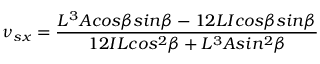<formula> <loc_0><loc_0><loc_500><loc_500>\nu { _ { s x } } = \frac { L ^ { 3 } A \cos \beta \sin \beta - 1 2 L I \cos \beta \sin \beta } { 1 2 I L \cos ^ { 2 } \beta + L ^ { 3 } A \sin ^ { 2 } \beta }</formula> 